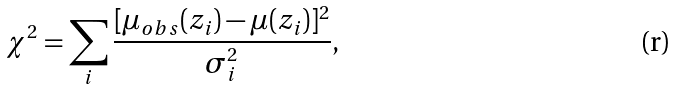Convert formula to latex. <formula><loc_0><loc_0><loc_500><loc_500>\chi ^ { 2 } = \sum _ { i } \frac { [ \mu _ { o b s } ( z _ { i } ) - \mu ( z _ { i } ) ] ^ { 2 } } { \sigma ^ { 2 } _ { i } } ,</formula> 